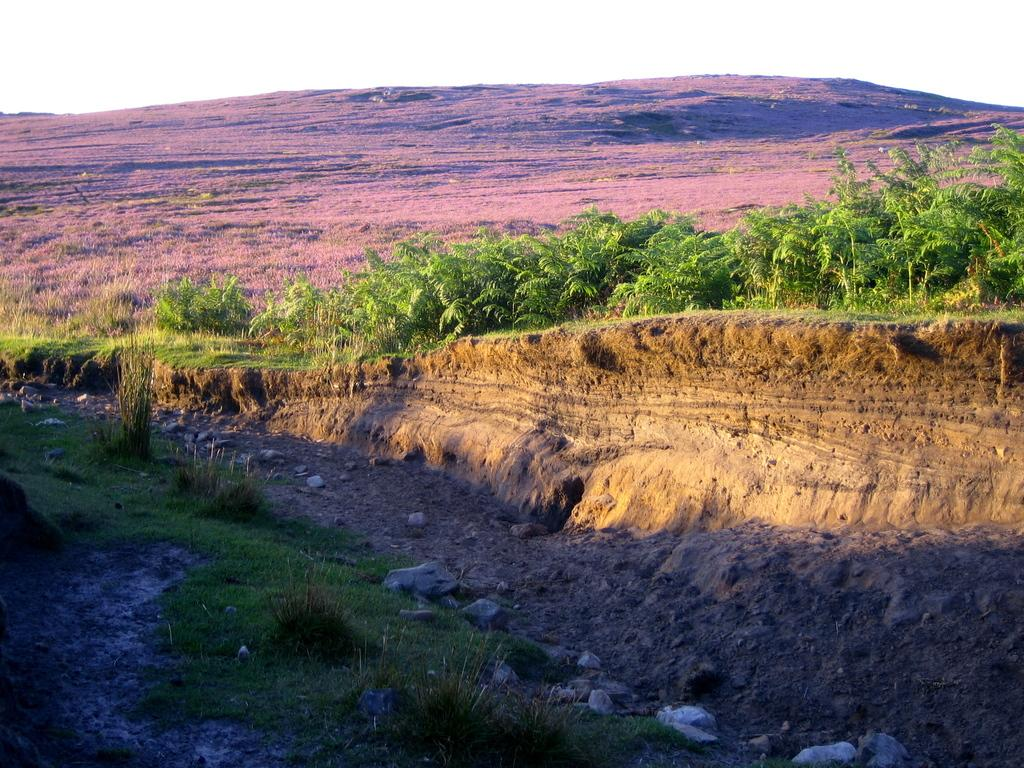What type of vegetation is present in the image? There are many trees, plants, and grass in the image. What can be found on the ground in the image? There are stones in the image. What is visible in the background of the image? There is a mountain in the background of the image. What is visible at the top of the image? The sky is visible at the top of the image. What type of pot is being used by the achiever in the image? There is no achiever or pot present in the image. What cable is being used to connect the trees in the image? There are no cables connecting the trees in the image; they are separate entities. 